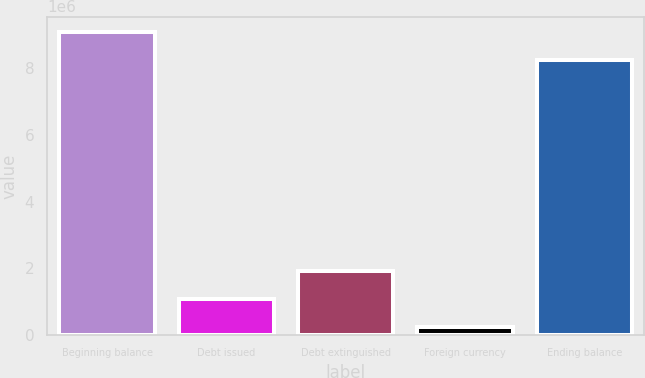Convert chart. <chart><loc_0><loc_0><loc_500><loc_500><bar_chart><fcel>Beginning balance<fcel>Debt issued<fcel>Debt extinguished<fcel>Foreign currency<fcel>Ending balance<nl><fcel>9.10054e+06<fcel>1.08122e+06<fcel>1.92173e+06<fcel>240720<fcel>8.26004e+06<nl></chart> 